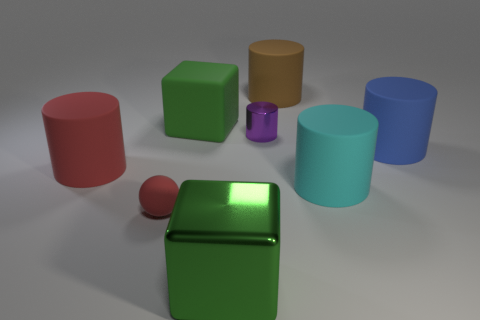Subtract all purple cylinders. How many cylinders are left? 4 Subtract all brown cylinders. How many cylinders are left? 4 Subtract all red cylinders. Subtract all red balls. How many cylinders are left? 4 Add 1 small red rubber balls. How many objects exist? 9 Subtract all spheres. How many objects are left? 7 Add 1 big gray rubber cylinders. How many big gray rubber cylinders exist? 1 Subtract 0 brown cubes. How many objects are left? 8 Subtract all metallic things. Subtract all brown matte objects. How many objects are left? 5 Add 7 purple cylinders. How many purple cylinders are left? 8 